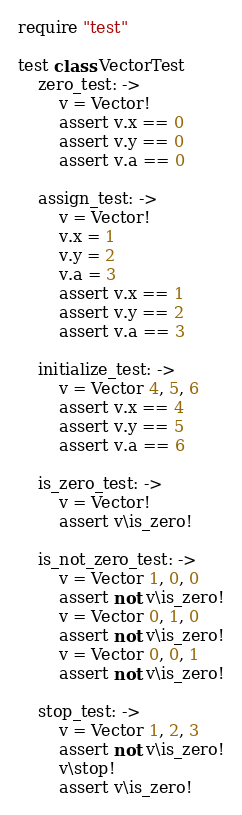Convert code to text. <code><loc_0><loc_0><loc_500><loc_500><_MoonScript_>require "test"

test class VectorTest
	zero_test: ->
		v = Vector!
		assert v.x == 0
		assert v.y == 0
		assert v.a == 0

	assign_test: ->
		v = Vector!
		v.x = 1
		v.y = 2
		v.a = 3
		assert v.x == 1
		assert v.y == 2
		assert v.a == 3

	initialize_test: ->
		v = Vector 4, 5, 6
		assert v.x == 4
		assert v.y == 5
		assert v.a == 6

	is_zero_test: ->
		v = Vector!
		assert v\is_zero!

	is_not_zero_test: ->
		v = Vector 1, 0, 0
		assert not v\is_zero!
		v = Vector 0, 1, 0
		assert not v\is_zero!
		v = Vector 0, 0, 1
		assert not v\is_zero!

	stop_test: ->
		v = Vector 1, 2, 3
		assert not v\is_zero!
		v\stop!
		assert v\is_zero!</code> 